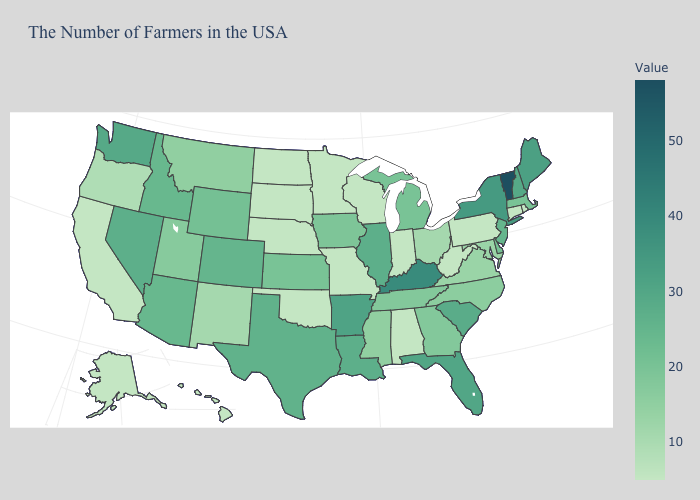Which states hav the highest value in the South?
Keep it brief. Kentucky. Does Delaware have a lower value than New Hampshire?
Be succinct. Yes. Does New Mexico have the highest value in the West?
Short answer required. No. 